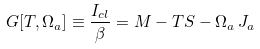<formula> <loc_0><loc_0><loc_500><loc_500>G [ T , \Omega _ { a } ] \equiv \frac { I _ { c l } } { \beta } = M - T S - \Omega _ { a } \, J _ { a }</formula> 